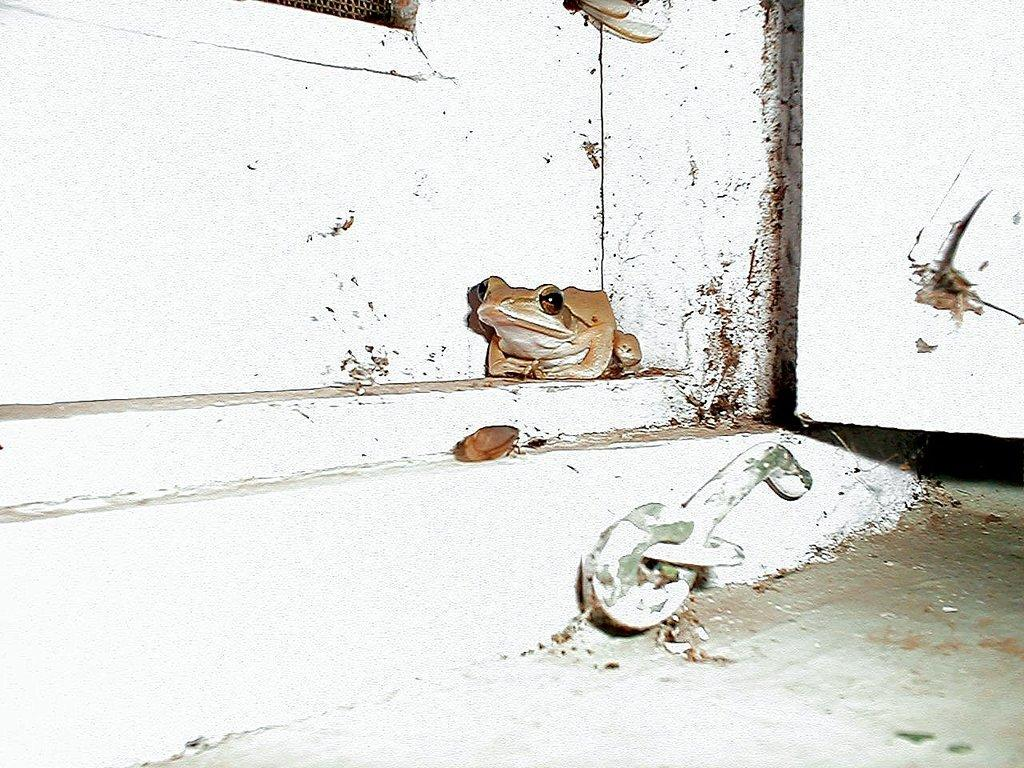How many steps are visible in the image? There are two steps in the image. What is located on the first step? There is a frog on the first step. What can be seen behind the frog? There is a wall behind the frog. What type of cough does the frog have in the image? There is no indication of a cough in the image, as it features a frog on a step with a wall behind it. Who is the representative of the frog in the image? There is no representative mentioned or implied in the image, as it simply shows a frog on a step with a wall behind it. 